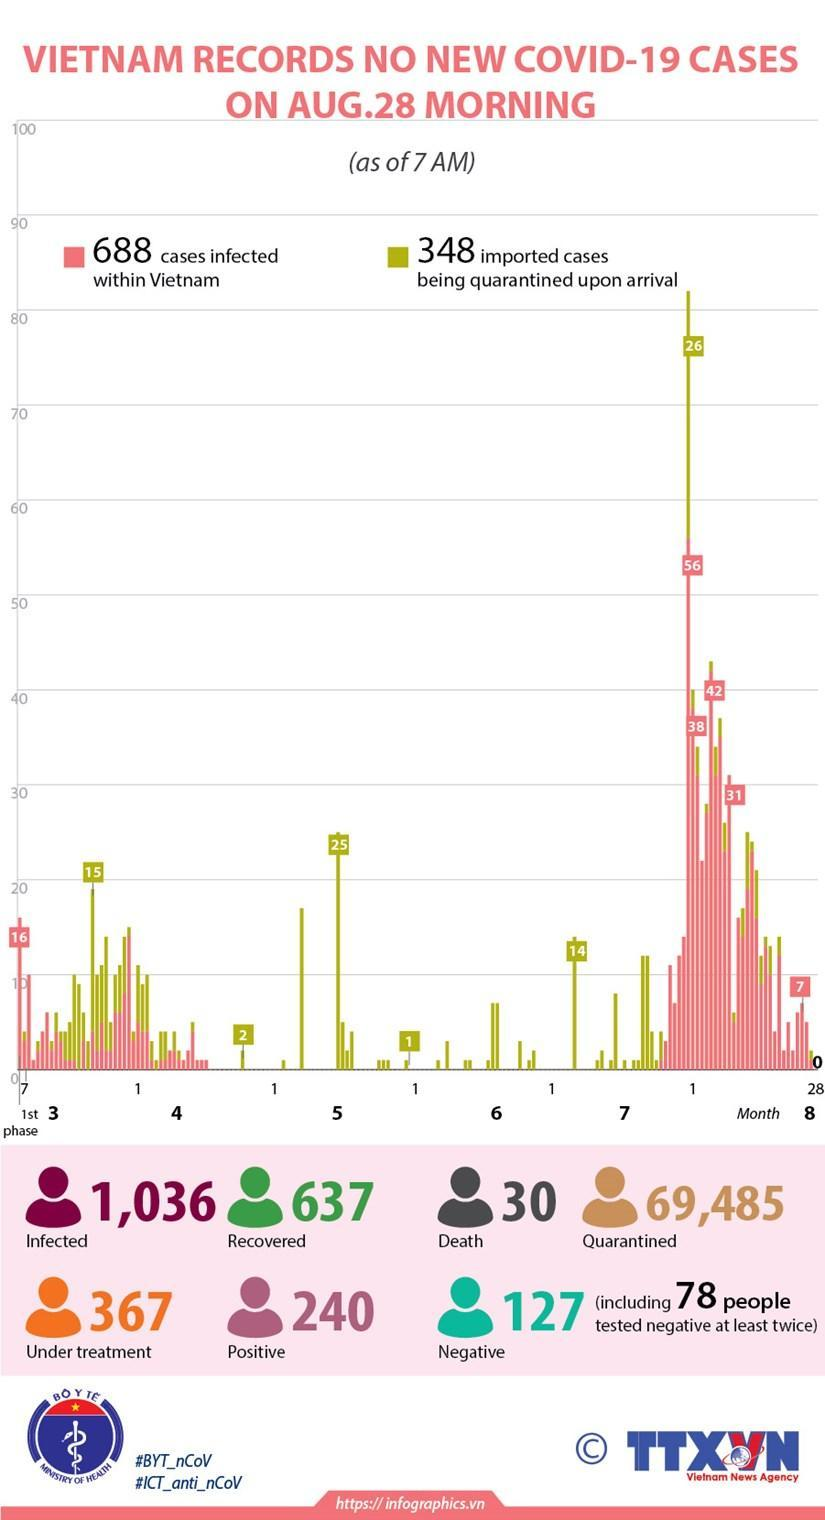How many test results turn positive in Vietnam as on 28th August?
Answer the question with a short phrase. 240 How many people in Vietnam got died due to corona? 30 What is the no of people who successfully came out of disease? 637 How many samples turn negative at first time check? 49 How many test results still showed the presence of virus when tested on 28th August? 127 How many cases reported in Vietnam got the infection from outside of Vietnam? 348 How many people are advised to stay home? 69,485 How many people are hospitalised in Vietnam as on 28th August? 367 What is the overall no of people who are infected in Vietnam? 1,036 